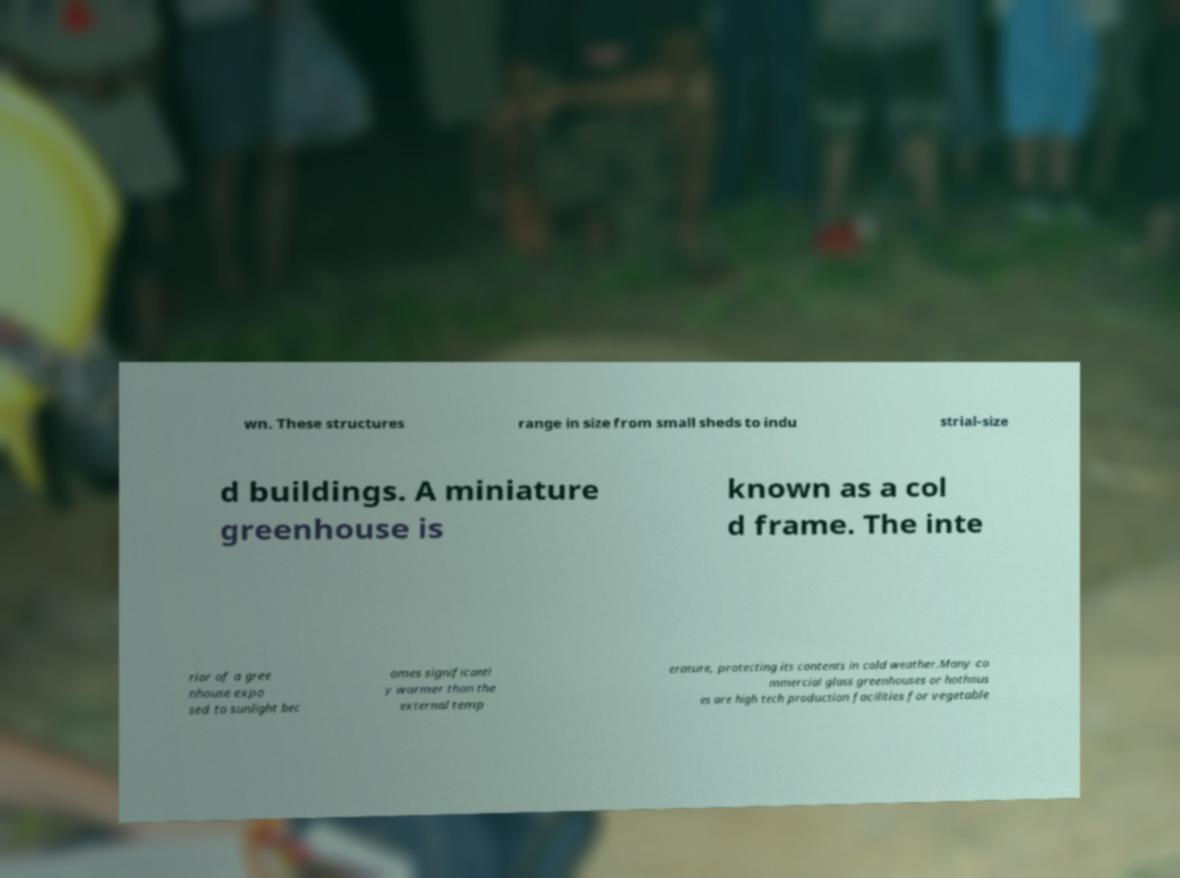Could you assist in decoding the text presented in this image and type it out clearly? wn. These structures range in size from small sheds to indu strial-size d buildings. A miniature greenhouse is known as a col d frame. The inte rior of a gree nhouse expo sed to sunlight bec omes significantl y warmer than the external temp erature, protecting its contents in cold weather.Many co mmercial glass greenhouses or hothous es are high tech production facilities for vegetable 